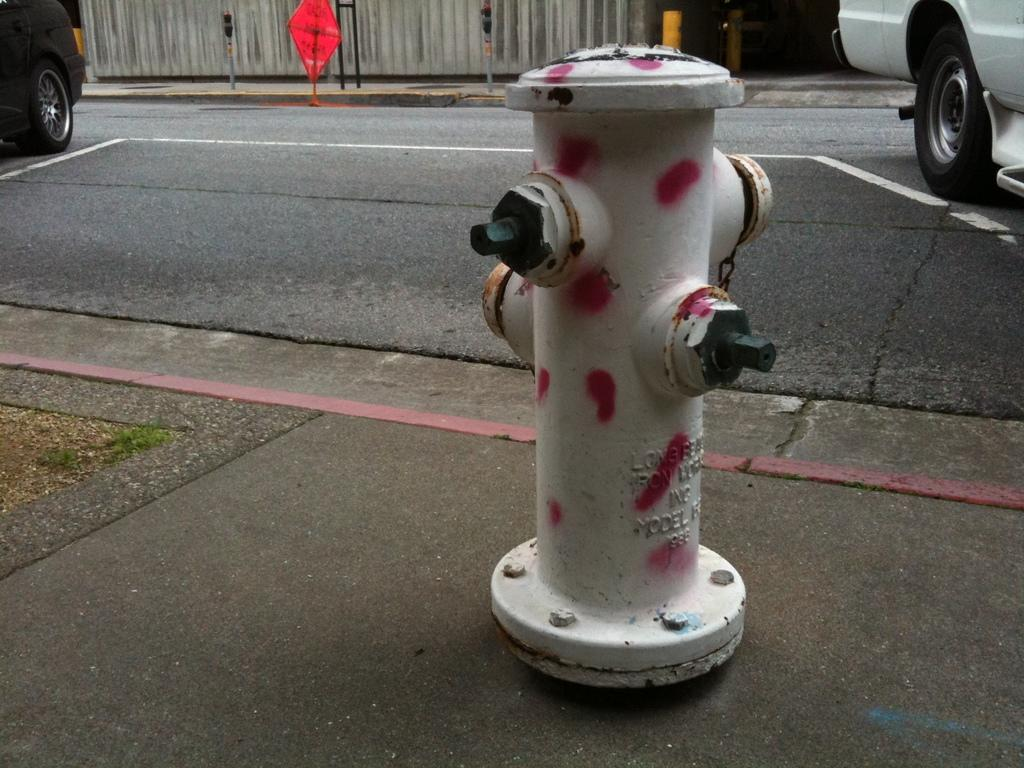What safety device can be seen beside the road in the image? There is a fire extinguisher beside the road in the image. What is happening on the road in the image? Vehicles are moving on the road in the image. What type of fencing can be seen in the background of the image? There is a wooden fencing in the background of the image. What type of canvas is being used by the police officer in the image? There is no canvas or police officer present in the image. What type of cart is being pulled by the horse in the image? There is no cart or horse present in the image. 